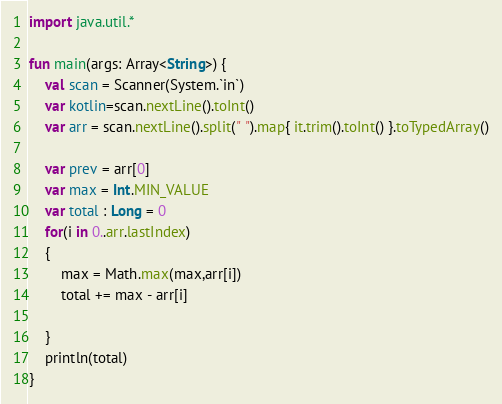Convert code to text. <code><loc_0><loc_0><loc_500><loc_500><_Kotlin_>import java.util.*

fun main(args: Array<String>) {
    val scan = Scanner(System.`in`)
    var kotlin=scan.nextLine().toInt()
    var arr = scan.nextLine().split(" ").map{ it.trim().toInt() }.toTypedArray()

    var prev = arr[0]
    var max = Int.MIN_VALUE
    var total : Long = 0
    for(i in 0..arr.lastIndex)
    {
        max = Math.max(max,arr[i])
        total += max - arr[i]

    }
    println(total)
}
</code> 